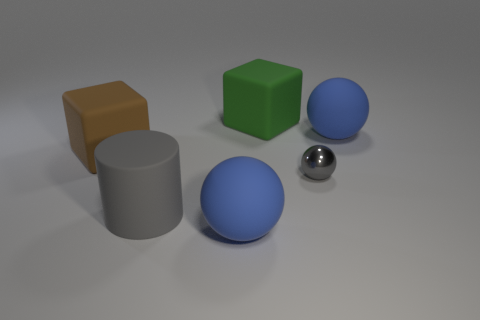What is the color of the thing that is behind the blue thing right of the blue rubber object in front of the gray cylinder?
Ensure brevity in your answer.  Green. Do the big gray thing and the small ball have the same material?
Offer a terse response. No. There is a big ball in front of the big block that is to the left of the big cylinder; is there a ball that is behind it?
Offer a terse response. Yes. Is the tiny metal object the same color as the large matte cylinder?
Offer a terse response. Yes. Are there fewer big brown cubes than small brown metallic balls?
Ensure brevity in your answer.  No. Is the material of the large blue object to the right of the green matte thing the same as the gray thing that is on the right side of the big green rubber object?
Offer a terse response. No. Are there fewer big rubber cylinders left of the cylinder than cyan metallic spheres?
Provide a succinct answer. No. How many brown matte things are to the right of the large rubber ball that is on the right side of the large green matte object?
Provide a succinct answer. 0. There is a rubber object that is both to the right of the gray rubber cylinder and in front of the tiny gray thing; what size is it?
Your response must be concise. Large. Is there anything else that has the same material as the green block?
Your response must be concise. Yes. 